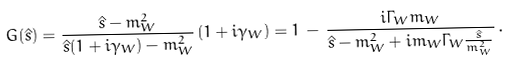<formula> <loc_0><loc_0><loc_500><loc_500>G ( \hat { s } ) = { \frac { \hat { s } - m _ { W } ^ { 2 } } { \hat { s } ( 1 + i \gamma _ { W } ) - m _ { W } ^ { 2 } } } \, ( 1 + i \gamma _ { W } ) = 1 \, - \, { \frac { i \Gamma _ { W } m _ { W } } { \hat { s } - m _ { W } ^ { 2 } + i m _ { W } \Gamma _ { W } { \frac { \hat { s } } { m _ { W } ^ { 2 } } } } } \, .</formula> 